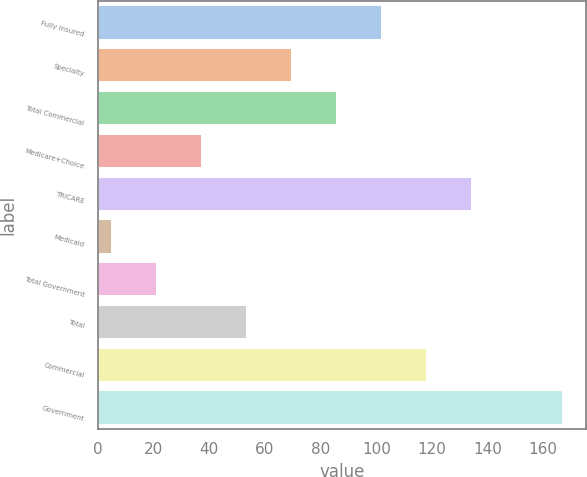Convert chart. <chart><loc_0><loc_0><loc_500><loc_500><bar_chart><fcel>Fully insured<fcel>Specialty<fcel>Total Commercial<fcel>Medicare+Choice<fcel>TRICARE<fcel>Medicaid<fcel>Total Government<fcel>Total<fcel>Commercial<fcel>Government<nl><fcel>102.16<fcel>69.74<fcel>85.95<fcel>37.32<fcel>134.58<fcel>4.9<fcel>21.11<fcel>53.53<fcel>118.37<fcel>167<nl></chart> 